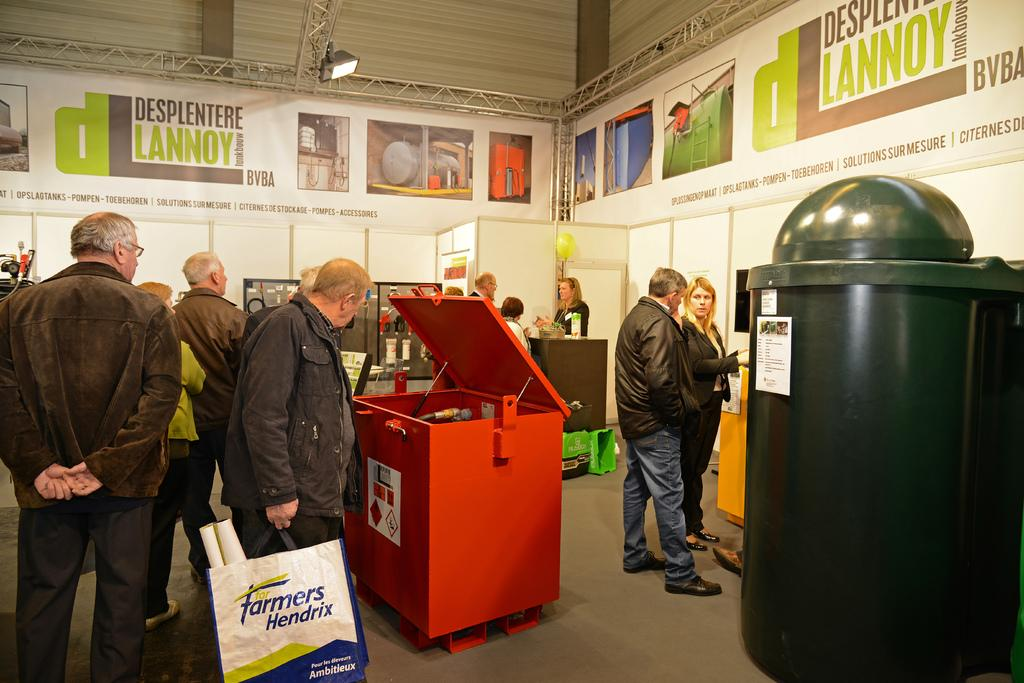<image>
Relay a brief, clear account of the picture shown. people inside of a event for Desplentere Lannoy 